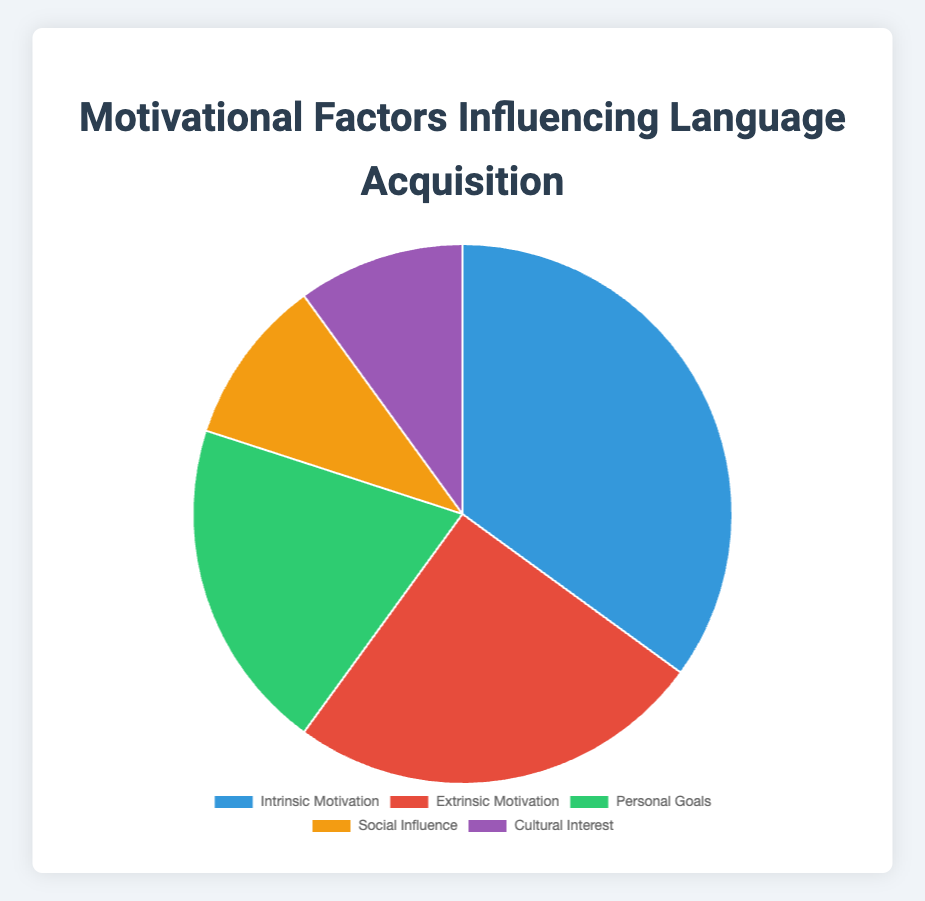What's the total percentage of motivational factors attributed to external influences (Extrinsic Motivation and Social Influence)? To find the total percentage of external influences, we need to add the percentages of Extrinsic Motivation and Social Influence: 25% + 10% = 35%
Answer: 35% Which motivational factor has the lowest percentage? By examining the chart, we see that both Social Influence and Cultural Interest share the lowest percentage at 10% each.
Answer: Social Influence and Cultural Interest How much greater is the percentage of Intrinsic Motivation compared to Personal Goals? Subtract the percentage of Personal Goals from the percentage of Intrinsic Motivation: 35% - 20% = 15%
Answer: 15% Which motivational factor is represented by the green color in the chart? By matching the color to the legend, the green color corresponds to Personal Goals.
Answer: Personal Goals Which two factors combined make up half of the motivational influences? We need to identify two factors whose percentages sum up to 50%. Intrinsic Motivation (35%) + Extrinsic Motivation (25%) = 60%. This combination exceeds 50%, so we try Personal Goals (20%) + Extrinsic Motivation (25%) + Social Influence (10%) + Cultural Interest (10%) = 50%. Therefore, Personal Goals and Extrinsic Motivation together make up half.
Answer: Personal Goals and Extrinsic Motivation What is the difference in percentage between the highest and lowest motivational factors? To find the difference, subtract the lowest percentage (10% from either Social Influence or Cultural Interest) from the highest percentage (35% from Intrinsic Motivation): 35% - 10% = 25%
Answer: 25% What motivational factor is indicated by the purple segment in the pie chart? The purple color corresponds to Cultural Interest, according to the chart legend.
Answer: Cultural Interest If we group Social Influence and Cultural Interest together, what fraction of the total motivation do they constitute? First, find the combined percentage of Social Influence and Cultural Interest: 10% + 10% = 20%. Then, express this as a fraction of the total (100%): 20/100 = 1/5
Answer: 1/5 What percentage of motivational factors are attributed to motivations other than Intrinsic Motivation? Calculate the combined percentage of all factors except Intrinsic Motivation by subtracting Intrinsic Motivation's percentage from 100%: 100% - 35% = 65%
Answer: 65% What factor is represented by the slice colored red? The red color corresponds to Extrinsic Motivation as indicated by the legend.
Answer: Extrinsic Motivation 